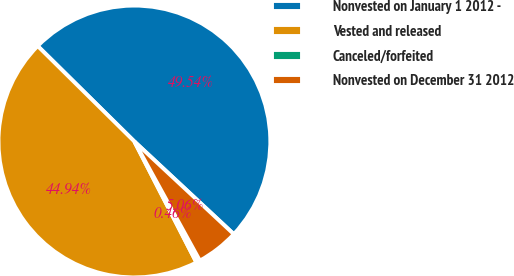Convert chart to OTSL. <chart><loc_0><loc_0><loc_500><loc_500><pie_chart><fcel>Nonvested on January 1 2012 -<fcel>Vested and released<fcel>Canceled/forfeited<fcel>Nonvested on December 31 2012<nl><fcel>49.54%<fcel>44.94%<fcel>0.46%<fcel>5.06%<nl></chart> 